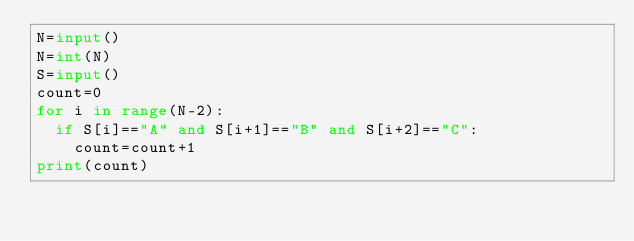<code> <loc_0><loc_0><loc_500><loc_500><_Python_>N=input()
N=int(N)
S=input()
count=0
for i in range(N-2):
  if S[i]=="A" and S[i+1]=="B" and S[i+2]=="C":
    count=count+1
print(count)</code> 